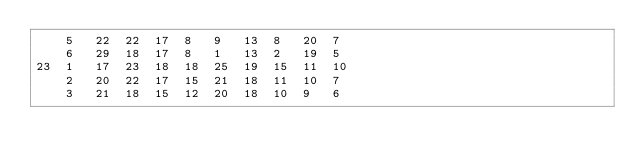<code> <loc_0><loc_0><loc_500><loc_500><_ObjectiveC_>	5	22	22	17	8	9	13	8	20	7	
	6	29	18	17	8	1	13	2	19	5	
23	1	17	23	18	18	25	19	15	11	10	
	2	20	22	17	15	21	18	11	10	7	
	3	21	18	15	12	20	18	10	9	6	</code> 